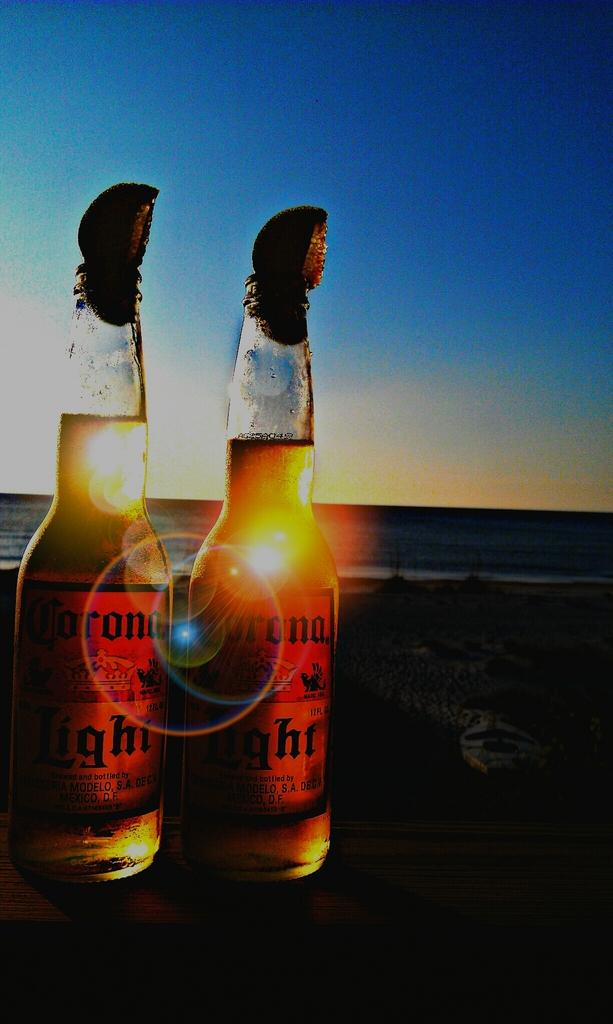Provide a one-sentence caption for the provided image. TWO BOTTLES OF CORONA LIGHTS SITTING ON A TABLE ON THE BEACH. 